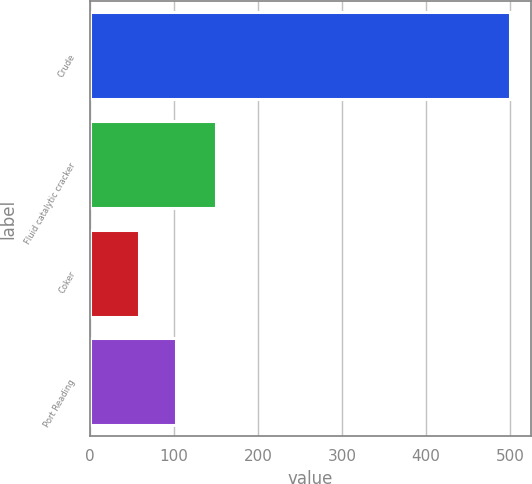<chart> <loc_0><loc_0><loc_500><loc_500><bar_chart><fcel>Crude<fcel>Fluid catalytic cracker<fcel>Coker<fcel>Port Reading<nl><fcel>500<fcel>150<fcel>58<fcel>102.2<nl></chart> 